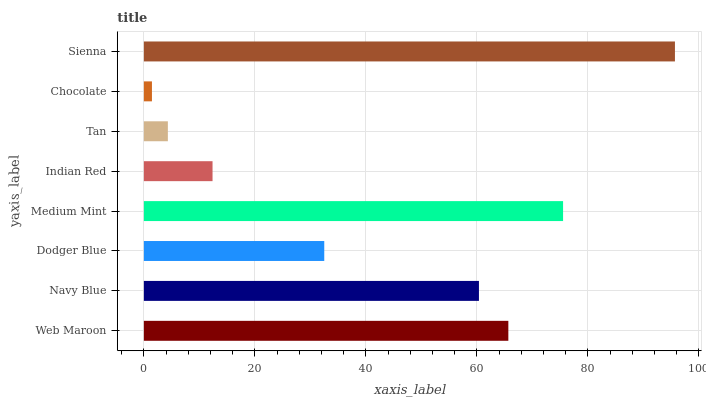Is Chocolate the minimum?
Answer yes or no. Yes. Is Sienna the maximum?
Answer yes or no. Yes. Is Navy Blue the minimum?
Answer yes or no. No. Is Navy Blue the maximum?
Answer yes or no. No. Is Web Maroon greater than Navy Blue?
Answer yes or no. Yes. Is Navy Blue less than Web Maroon?
Answer yes or no. Yes. Is Navy Blue greater than Web Maroon?
Answer yes or no. No. Is Web Maroon less than Navy Blue?
Answer yes or no. No. Is Navy Blue the high median?
Answer yes or no. Yes. Is Dodger Blue the low median?
Answer yes or no. Yes. Is Dodger Blue the high median?
Answer yes or no. No. Is Sienna the low median?
Answer yes or no. No. 